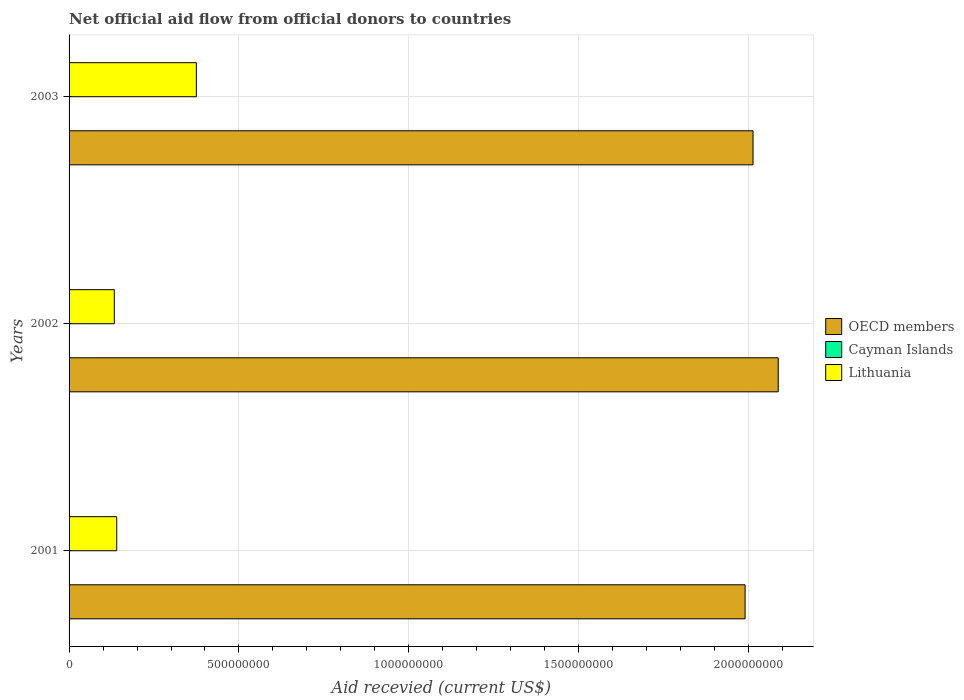How many different coloured bars are there?
Make the answer very short. 2. Are the number of bars on each tick of the Y-axis equal?
Your response must be concise. Yes. How many bars are there on the 3rd tick from the bottom?
Your answer should be very brief. 2. What is the total aid received in Cayman Islands in 2003?
Offer a terse response. 0. Across all years, what is the maximum total aid received in OECD members?
Your answer should be compact. 2.09e+09. Across all years, what is the minimum total aid received in OECD members?
Your answer should be compact. 1.99e+09. What is the total total aid received in OECD members in the graph?
Give a very brief answer. 6.09e+09. What is the difference between the total aid received in OECD members in 2001 and that in 2002?
Ensure brevity in your answer.  -9.76e+07. What is the difference between the total aid received in Cayman Islands in 2001 and the total aid received in OECD members in 2002?
Your answer should be compact. -2.09e+09. What is the average total aid received in Lithuania per year?
Your answer should be very brief. 2.16e+08. In the year 2001, what is the difference between the total aid received in OECD members and total aid received in Lithuania?
Your answer should be very brief. 1.85e+09. What is the ratio of the total aid received in Lithuania in 2002 to that in 2003?
Keep it short and to the point. 0.36. Is the total aid received in OECD members in 2001 less than that in 2002?
Keep it short and to the point. Yes. What is the difference between the highest and the second highest total aid received in OECD members?
Give a very brief answer. 7.41e+07. What is the difference between the highest and the lowest total aid received in Lithuania?
Your answer should be very brief. 2.41e+08. How many years are there in the graph?
Offer a terse response. 3. Does the graph contain any zero values?
Provide a succinct answer. Yes. What is the title of the graph?
Your answer should be very brief. Net official aid flow from official donors to countries. Does "Switzerland" appear as one of the legend labels in the graph?
Your answer should be very brief. No. What is the label or title of the X-axis?
Make the answer very short. Aid recevied (current US$). What is the label or title of the Y-axis?
Ensure brevity in your answer.  Years. What is the Aid recevied (current US$) of OECD members in 2001?
Ensure brevity in your answer.  1.99e+09. What is the Aid recevied (current US$) in Cayman Islands in 2001?
Offer a very short reply. 0. What is the Aid recevied (current US$) of Lithuania in 2001?
Your response must be concise. 1.40e+08. What is the Aid recevied (current US$) of OECD members in 2002?
Keep it short and to the point. 2.09e+09. What is the Aid recevied (current US$) of Lithuania in 2002?
Provide a short and direct response. 1.33e+08. What is the Aid recevied (current US$) of OECD members in 2003?
Your answer should be very brief. 2.01e+09. What is the Aid recevied (current US$) of Cayman Islands in 2003?
Ensure brevity in your answer.  0. What is the Aid recevied (current US$) in Lithuania in 2003?
Offer a terse response. 3.75e+08. Across all years, what is the maximum Aid recevied (current US$) in OECD members?
Provide a short and direct response. 2.09e+09. Across all years, what is the maximum Aid recevied (current US$) in Lithuania?
Your answer should be very brief. 3.75e+08. Across all years, what is the minimum Aid recevied (current US$) in OECD members?
Provide a short and direct response. 1.99e+09. Across all years, what is the minimum Aid recevied (current US$) in Lithuania?
Your response must be concise. 1.33e+08. What is the total Aid recevied (current US$) of OECD members in the graph?
Offer a very short reply. 6.09e+09. What is the total Aid recevied (current US$) in Cayman Islands in the graph?
Offer a very short reply. 0. What is the total Aid recevied (current US$) of Lithuania in the graph?
Keep it short and to the point. 6.48e+08. What is the difference between the Aid recevied (current US$) in OECD members in 2001 and that in 2002?
Provide a succinct answer. -9.76e+07. What is the difference between the Aid recevied (current US$) of Lithuania in 2001 and that in 2002?
Make the answer very short. 7.02e+06. What is the difference between the Aid recevied (current US$) in OECD members in 2001 and that in 2003?
Provide a succinct answer. -2.34e+07. What is the difference between the Aid recevied (current US$) in Lithuania in 2001 and that in 2003?
Keep it short and to the point. -2.34e+08. What is the difference between the Aid recevied (current US$) of OECD members in 2002 and that in 2003?
Provide a succinct answer. 7.41e+07. What is the difference between the Aid recevied (current US$) of Lithuania in 2002 and that in 2003?
Your answer should be very brief. -2.41e+08. What is the difference between the Aid recevied (current US$) of OECD members in 2001 and the Aid recevied (current US$) of Lithuania in 2002?
Make the answer very short. 1.86e+09. What is the difference between the Aid recevied (current US$) in OECD members in 2001 and the Aid recevied (current US$) in Lithuania in 2003?
Ensure brevity in your answer.  1.62e+09. What is the difference between the Aid recevied (current US$) in OECD members in 2002 and the Aid recevied (current US$) in Lithuania in 2003?
Your answer should be very brief. 1.71e+09. What is the average Aid recevied (current US$) in OECD members per year?
Make the answer very short. 2.03e+09. What is the average Aid recevied (current US$) of Cayman Islands per year?
Give a very brief answer. 0. What is the average Aid recevied (current US$) in Lithuania per year?
Your answer should be very brief. 2.16e+08. In the year 2001, what is the difference between the Aid recevied (current US$) of OECD members and Aid recevied (current US$) of Lithuania?
Make the answer very short. 1.85e+09. In the year 2002, what is the difference between the Aid recevied (current US$) of OECD members and Aid recevied (current US$) of Lithuania?
Offer a very short reply. 1.95e+09. In the year 2003, what is the difference between the Aid recevied (current US$) in OECD members and Aid recevied (current US$) in Lithuania?
Your answer should be compact. 1.64e+09. What is the ratio of the Aid recevied (current US$) of OECD members in 2001 to that in 2002?
Your response must be concise. 0.95. What is the ratio of the Aid recevied (current US$) in Lithuania in 2001 to that in 2002?
Offer a very short reply. 1.05. What is the ratio of the Aid recevied (current US$) in OECD members in 2001 to that in 2003?
Your response must be concise. 0.99. What is the ratio of the Aid recevied (current US$) of Lithuania in 2001 to that in 2003?
Your answer should be very brief. 0.37. What is the ratio of the Aid recevied (current US$) in OECD members in 2002 to that in 2003?
Provide a succinct answer. 1.04. What is the ratio of the Aid recevied (current US$) of Lithuania in 2002 to that in 2003?
Offer a terse response. 0.36. What is the difference between the highest and the second highest Aid recevied (current US$) of OECD members?
Make the answer very short. 7.41e+07. What is the difference between the highest and the second highest Aid recevied (current US$) in Lithuania?
Offer a terse response. 2.34e+08. What is the difference between the highest and the lowest Aid recevied (current US$) of OECD members?
Offer a terse response. 9.76e+07. What is the difference between the highest and the lowest Aid recevied (current US$) in Lithuania?
Your answer should be compact. 2.41e+08. 